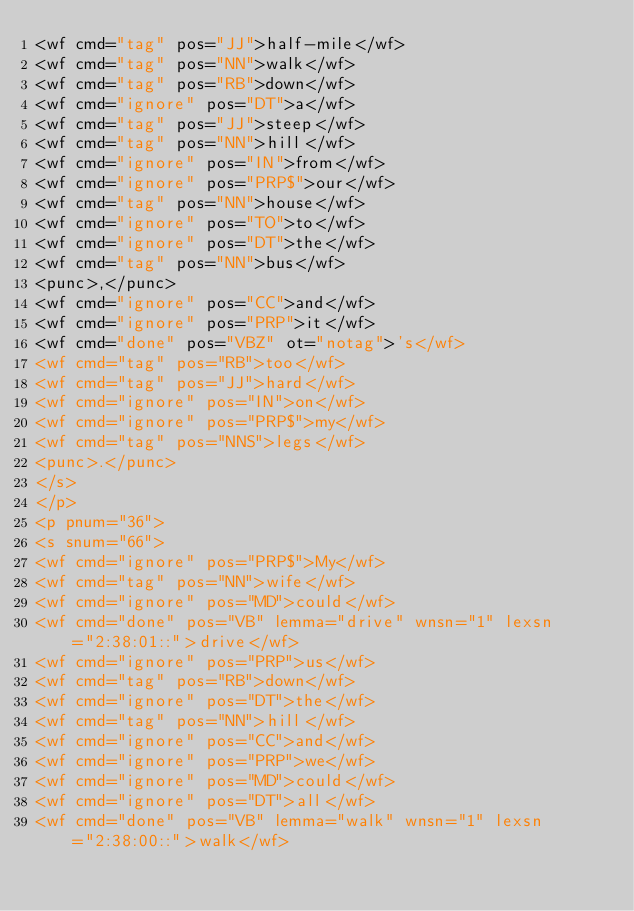<code> <loc_0><loc_0><loc_500><loc_500><_XML_><wf cmd="tag" pos="JJ">half-mile</wf>
<wf cmd="tag" pos="NN">walk</wf>
<wf cmd="tag" pos="RB">down</wf>
<wf cmd="ignore" pos="DT">a</wf>
<wf cmd="tag" pos="JJ">steep</wf>
<wf cmd="tag" pos="NN">hill</wf>
<wf cmd="ignore" pos="IN">from</wf>
<wf cmd="ignore" pos="PRP$">our</wf>
<wf cmd="tag" pos="NN">house</wf>
<wf cmd="ignore" pos="TO">to</wf>
<wf cmd="ignore" pos="DT">the</wf>
<wf cmd="tag" pos="NN">bus</wf>
<punc>,</punc>
<wf cmd="ignore" pos="CC">and</wf>
<wf cmd="ignore" pos="PRP">it</wf>
<wf cmd="done" pos="VBZ" ot="notag">'s</wf>
<wf cmd="tag" pos="RB">too</wf>
<wf cmd="tag" pos="JJ">hard</wf>
<wf cmd="ignore" pos="IN">on</wf>
<wf cmd="ignore" pos="PRP$">my</wf>
<wf cmd="tag" pos="NNS">legs</wf>
<punc>.</punc>
</s>
</p>
<p pnum="36">
<s snum="66">
<wf cmd="ignore" pos="PRP$">My</wf>
<wf cmd="tag" pos="NN">wife</wf>
<wf cmd="ignore" pos="MD">could</wf>
<wf cmd="done" pos="VB" lemma="drive" wnsn="1" lexsn="2:38:01::">drive</wf>
<wf cmd="ignore" pos="PRP">us</wf>
<wf cmd="tag" pos="RB">down</wf>
<wf cmd="ignore" pos="DT">the</wf>
<wf cmd="tag" pos="NN">hill</wf>
<wf cmd="ignore" pos="CC">and</wf>
<wf cmd="ignore" pos="PRP">we</wf>
<wf cmd="ignore" pos="MD">could</wf>
<wf cmd="ignore" pos="DT">all</wf>
<wf cmd="done" pos="VB" lemma="walk" wnsn="1" lexsn="2:38:00::">walk</wf></code> 